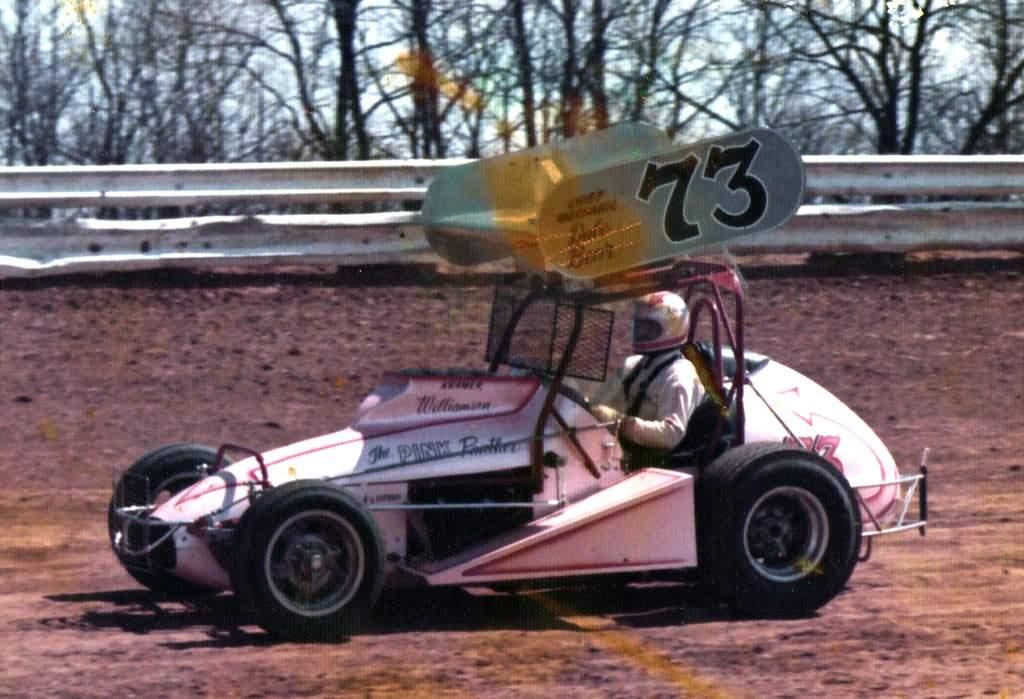What number is the car?
Make the answer very short. 73. 